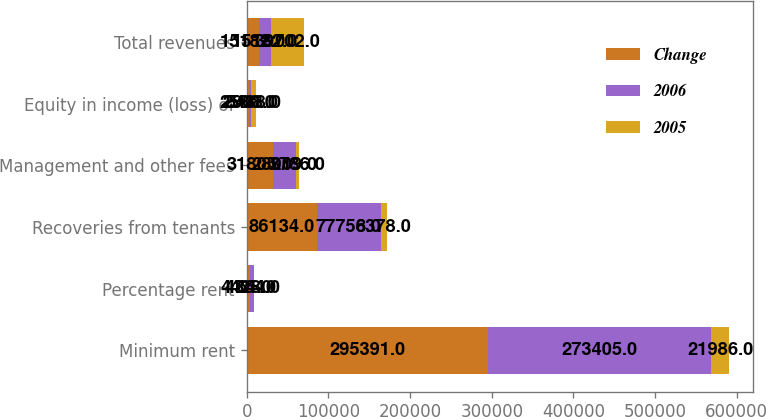Convert chart to OTSL. <chart><loc_0><loc_0><loc_500><loc_500><stacked_bar_chart><ecel><fcel>Minimum rent<fcel>Percentage rent<fcel>Recoveries from tenants<fcel>Management and other fees<fcel>Equity in income (loss) of<fcel>Total revenues<nl><fcel>Change<fcel>295391<fcel>4428<fcel>86134<fcel>31805<fcel>2580<fcel>15182<nl><fcel>2006<fcel>273405<fcel>4364<fcel>77756<fcel>28019<fcel>2908<fcel>15182<nl><fcel>2005<fcel>21986<fcel>64<fcel>8378<fcel>3786<fcel>5488<fcel>39702<nl></chart> 